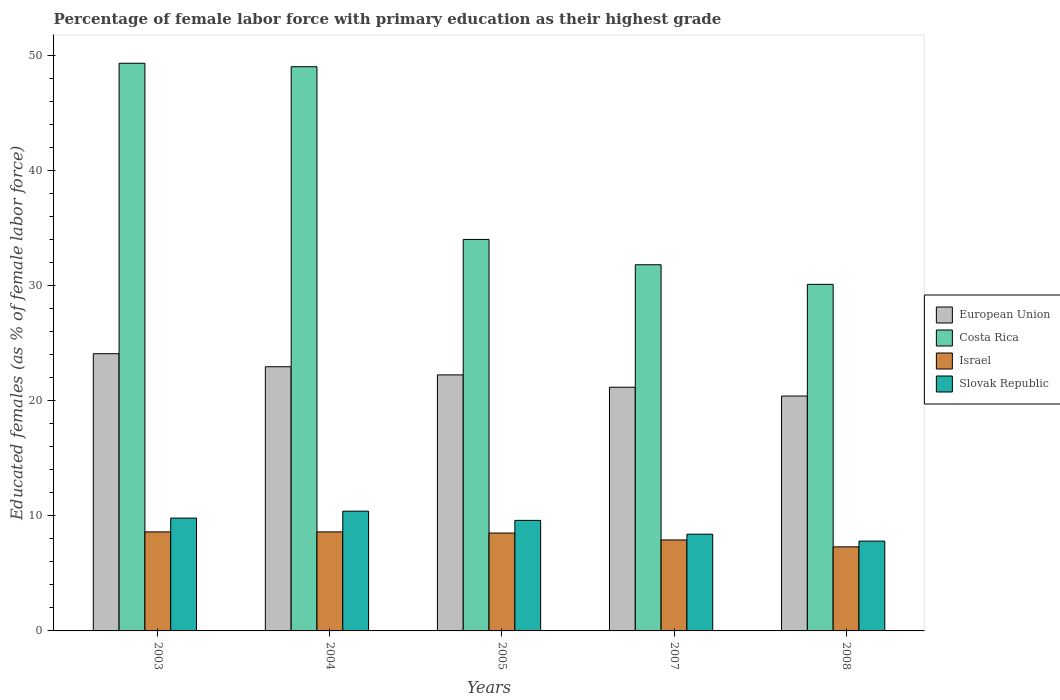How many different coloured bars are there?
Keep it short and to the point. 4. How many bars are there on the 3rd tick from the right?
Provide a short and direct response. 4. What is the label of the 4th group of bars from the left?
Provide a succinct answer. 2007. In how many cases, is the number of bars for a given year not equal to the number of legend labels?
Offer a terse response. 0. What is the percentage of female labor force with primary education in Israel in 2007?
Offer a very short reply. 7.9. Across all years, what is the maximum percentage of female labor force with primary education in Israel?
Give a very brief answer. 8.6. Across all years, what is the minimum percentage of female labor force with primary education in Slovak Republic?
Your response must be concise. 7.8. In which year was the percentage of female labor force with primary education in Israel minimum?
Provide a succinct answer. 2008. What is the total percentage of female labor force with primary education in Slovak Republic in the graph?
Keep it short and to the point. 46. What is the difference between the percentage of female labor force with primary education in Slovak Republic in 2007 and that in 2008?
Keep it short and to the point. 0.6. What is the difference between the percentage of female labor force with primary education in European Union in 2008 and the percentage of female labor force with primary education in Costa Rica in 2007?
Give a very brief answer. -11.4. What is the average percentage of female labor force with primary education in Israel per year?
Keep it short and to the point. 8.18. In the year 2008, what is the difference between the percentage of female labor force with primary education in Slovak Republic and percentage of female labor force with primary education in Israel?
Provide a short and direct response. 0.5. In how many years, is the percentage of female labor force with primary education in Costa Rica greater than 38 %?
Give a very brief answer. 2. What is the ratio of the percentage of female labor force with primary education in Slovak Republic in 2007 to that in 2008?
Ensure brevity in your answer.  1.08. Is the difference between the percentage of female labor force with primary education in Slovak Republic in 2003 and 2008 greater than the difference between the percentage of female labor force with primary education in Israel in 2003 and 2008?
Offer a very short reply. Yes. What is the difference between the highest and the second highest percentage of female labor force with primary education in European Union?
Give a very brief answer. 1.13. What is the difference between the highest and the lowest percentage of female labor force with primary education in Costa Rica?
Make the answer very short. 19.2. In how many years, is the percentage of female labor force with primary education in European Union greater than the average percentage of female labor force with primary education in European Union taken over all years?
Your response must be concise. 3. What does the 4th bar from the left in 2004 represents?
Offer a very short reply. Slovak Republic. What does the 1st bar from the right in 2004 represents?
Offer a very short reply. Slovak Republic. Are all the bars in the graph horizontal?
Your answer should be very brief. No. How many years are there in the graph?
Offer a very short reply. 5. What is the difference between two consecutive major ticks on the Y-axis?
Offer a very short reply. 10. Are the values on the major ticks of Y-axis written in scientific E-notation?
Provide a succinct answer. No. Where does the legend appear in the graph?
Your answer should be compact. Center right. How are the legend labels stacked?
Your answer should be very brief. Vertical. What is the title of the graph?
Offer a terse response. Percentage of female labor force with primary education as their highest grade. Does "St. Martin (French part)" appear as one of the legend labels in the graph?
Provide a short and direct response. No. What is the label or title of the X-axis?
Make the answer very short. Years. What is the label or title of the Y-axis?
Your response must be concise. Educated females (as % of female labor force). What is the Educated females (as % of female labor force) in European Union in 2003?
Ensure brevity in your answer.  24.08. What is the Educated females (as % of female labor force) of Costa Rica in 2003?
Offer a terse response. 49.3. What is the Educated females (as % of female labor force) of Israel in 2003?
Keep it short and to the point. 8.6. What is the Educated females (as % of female labor force) of Slovak Republic in 2003?
Offer a very short reply. 9.8. What is the Educated females (as % of female labor force) of European Union in 2004?
Make the answer very short. 22.94. What is the Educated females (as % of female labor force) of Costa Rica in 2004?
Provide a short and direct response. 49. What is the Educated females (as % of female labor force) of Israel in 2004?
Provide a short and direct response. 8.6. What is the Educated females (as % of female labor force) of Slovak Republic in 2004?
Keep it short and to the point. 10.4. What is the Educated females (as % of female labor force) in European Union in 2005?
Make the answer very short. 22.24. What is the Educated females (as % of female labor force) in Costa Rica in 2005?
Provide a succinct answer. 34. What is the Educated females (as % of female labor force) of Israel in 2005?
Your answer should be very brief. 8.5. What is the Educated females (as % of female labor force) in Slovak Republic in 2005?
Provide a succinct answer. 9.6. What is the Educated females (as % of female labor force) of European Union in 2007?
Make the answer very short. 21.16. What is the Educated females (as % of female labor force) in Costa Rica in 2007?
Your answer should be very brief. 31.8. What is the Educated females (as % of female labor force) of Israel in 2007?
Keep it short and to the point. 7.9. What is the Educated females (as % of female labor force) in Slovak Republic in 2007?
Give a very brief answer. 8.4. What is the Educated females (as % of female labor force) in European Union in 2008?
Offer a terse response. 20.4. What is the Educated females (as % of female labor force) in Costa Rica in 2008?
Provide a short and direct response. 30.1. What is the Educated females (as % of female labor force) of Israel in 2008?
Offer a very short reply. 7.3. What is the Educated females (as % of female labor force) in Slovak Republic in 2008?
Keep it short and to the point. 7.8. Across all years, what is the maximum Educated females (as % of female labor force) in European Union?
Your answer should be compact. 24.08. Across all years, what is the maximum Educated females (as % of female labor force) of Costa Rica?
Your answer should be compact. 49.3. Across all years, what is the maximum Educated females (as % of female labor force) of Israel?
Make the answer very short. 8.6. Across all years, what is the maximum Educated females (as % of female labor force) in Slovak Republic?
Provide a short and direct response. 10.4. Across all years, what is the minimum Educated females (as % of female labor force) of European Union?
Provide a succinct answer. 20.4. Across all years, what is the minimum Educated females (as % of female labor force) in Costa Rica?
Your answer should be very brief. 30.1. Across all years, what is the minimum Educated females (as % of female labor force) of Israel?
Offer a terse response. 7.3. Across all years, what is the minimum Educated females (as % of female labor force) of Slovak Republic?
Your answer should be compact. 7.8. What is the total Educated females (as % of female labor force) in European Union in the graph?
Make the answer very short. 110.82. What is the total Educated females (as % of female labor force) of Costa Rica in the graph?
Your response must be concise. 194.2. What is the total Educated females (as % of female labor force) in Israel in the graph?
Your answer should be compact. 40.9. What is the difference between the Educated females (as % of female labor force) in European Union in 2003 and that in 2004?
Offer a terse response. 1.13. What is the difference between the Educated females (as % of female labor force) of Costa Rica in 2003 and that in 2004?
Your answer should be compact. 0.3. What is the difference between the Educated females (as % of female labor force) of Israel in 2003 and that in 2004?
Keep it short and to the point. 0. What is the difference between the Educated females (as % of female labor force) of Slovak Republic in 2003 and that in 2004?
Offer a terse response. -0.6. What is the difference between the Educated females (as % of female labor force) in European Union in 2003 and that in 2005?
Make the answer very short. 1.84. What is the difference between the Educated females (as % of female labor force) in Slovak Republic in 2003 and that in 2005?
Provide a succinct answer. 0.2. What is the difference between the Educated females (as % of female labor force) in European Union in 2003 and that in 2007?
Offer a terse response. 2.91. What is the difference between the Educated females (as % of female labor force) of Costa Rica in 2003 and that in 2007?
Your answer should be very brief. 17.5. What is the difference between the Educated females (as % of female labor force) in Israel in 2003 and that in 2007?
Offer a very short reply. 0.7. What is the difference between the Educated females (as % of female labor force) of Slovak Republic in 2003 and that in 2007?
Ensure brevity in your answer.  1.4. What is the difference between the Educated females (as % of female labor force) in European Union in 2003 and that in 2008?
Offer a terse response. 3.68. What is the difference between the Educated females (as % of female labor force) in Costa Rica in 2003 and that in 2008?
Your answer should be compact. 19.2. What is the difference between the Educated females (as % of female labor force) of Slovak Republic in 2003 and that in 2008?
Give a very brief answer. 2. What is the difference between the Educated females (as % of female labor force) of European Union in 2004 and that in 2005?
Offer a terse response. 0.71. What is the difference between the Educated females (as % of female labor force) in Costa Rica in 2004 and that in 2005?
Provide a short and direct response. 15. What is the difference between the Educated females (as % of female labor force) of Israel in 2004 and that in 2005?
Your response must be concise. 0.1. What is the difference between the Educated females (as % of female labor force) of European Union in 2004 and that in 2007?
Provide a succinct answer. 1.78. What is the difference between the Educated females (as % of female labor force) of Costa Rica in 2004 and that in 2007?
Provide a succinct answer. 17.2. What is the difference between the Educated females (as % of female labor force) in European Union in 2004 and that in 2008?
Provide a succinct answer. 2.55. What is the difference between the Educated females (as % of female labor force) of Costa Rica in 2004 and that in 2008?
Offer a terse response. 18.9. What is the difference between the Educated females (as % of female labor force) in Slovak Republic in 2004 and that in 2008?
Provide a succinct answer. 2.6. What is the difference between the Educated females (as % of female labor force) in European Union in 2005 and that in 2007?
Your answer should be compact. 1.07. What is the difference between the Educated females (as % of female labor force) of Israel in 2005 and that in 2007?
Ensure brevity in your answer.  0.6. What is the difference between the Educated females (as % of female labor force) in Slovak Republic in 2005 and that in 2007?
Give a very brief answer. 1.2. What is the difference between the Educated females (as % of female labor force) in European Union in 2005 and that in 2008?
Ensure brevity in your answer.  1.84. What is the difference between the Educated females (as % of female labor force) of Costa Rica in 2005 and that in 2008?
Your response must be concise. 3.9. What is the difference between the Educated females (as % of female labor force) of Israel in 2005 and that in 2008?
Make the answer very short. 1.2. What is the difference between the Educated females (as % of female labor force) of European Union in 2007 and that in 2008?
Offer a very short reply. 0.76. What is the difference between the Educated females (as % of female labor force) in Costa Rica in 2007 and that in 2008?
Offer a terse response. 1.7. What is the difference between the Educated females (as % of female labor force) of Israel in 2007 and that in 2008?
Your answer should be compact. 0.6. What is the difference between the Educated females (as % of female labor force) of European Union in 2003 and the Educated females (as % of female labor force) of Costa Rica in 2004?
Your answer should be very brief. -24.92. What is the difference between the Educated females (as % of female labor force) of European Union in 2003 and the Educated females (as % of female labor force) of Israel in 2004?
Keep it short and to the point. 15.48. What is the difference between the Educated females (as % of female labor force) of European Union in 2003 and the Educated females (as % of female labor force) of Slovak Republic in 2004?
Ensure brevity in your answer.  13.68. What is the difference between the Educated females (as % of female labor force) of Costa Rica in 2003 and the Educated females (as % of female labor force) of Israel in 2004?
Offer a terse response. 40.7. What is the difference between the Educated females (as % of female labor force) in Costa Rica in 2003 and the Educated females (as % of female labor force) in Slovak Republic in 2004?
Provide a succinct answer. 38.9. What is the difference between the Educated females (as % of female labor force) of European Union in 2003 and the Educated females (as % of female labor force) of Costa Rica in 2005?
Keep it short and to the point. -9.92. What is the difference between the Educated females (as % of female labor force) in European Union in 2003 and the Educated females (as % of female labor force) in Israel in 2005?
Provide a short and direct response. 15.58. What is the difference between the Educated females (as % of female labor force) in European Union in 2003 and the Educated females (as % of female labor force) in Slovak Republic in 2005?
Offer a very short reply. 14.48. What is the difference between the Educated females (as % of female labor force) in Costa Rica in 2003 and the Educated females (as % of female labor force) in Israel in 2005?
Give a very brief answer. 40.8. What is the difference between the Educated females (as % of female labor force) in Costa Rica in 2003 and the Educated females (as % of female labor force) in Slovak Republic in 2005?
Make the answer very short. 39.7. What is the difference between the Educated females (as % of female labor force) in European Union in 2003 and the Educated females (as % of female labor force) in Costa Rica in 2007?
Keep it short and to the point. -7.72. What is the difference between the Educated females (as % of female labor force) of European Union in 2003 and the Educated females (as % of female labor force) of Israel in 2007?
Keep it short and to the point. 16.18. What is the difference between the Educated females (as % of female labor force) in European Union in 2003 and the Educated females (as % of female labor force) in Slovak Republic in 2007?
Your response must be concise. 15.68. What is the difference between the Educated females (as % of female labor force) in Costa Rica in 2003 and the Educated females (as % of female labor force) in Israel in 2007?
Your answer should be compact. 41.4. What is the difference between the Educated females (as % of female labor force) of Costa Rica in 2003 and the Educated females (as % of female labor force) of Slovak Republic in 2007?
Your answer should be compact. 40.9. What is the difference between the Educated females (as % of female labor force) in European Union in 2003 and the Educated females (as % of female labor force) in Costa Rica in 2008?
Ensure brevity in your answer.  -6.02. What is the difference between the Educated females (as % of female labor force) in European Union in 2003 and the Educated females (as % of female labor force) in Israel in 2008?
Keep it short and to the point. 16.78. What is the difference between the Educated females (as % of female labor force) of European Union in 2003 and the Educated females (as % of female labor force) of Slovak Republic in 2008?
Offer a very short reply. 16.28. What is the difference between the Educated females (as % of female labor force) in Costa Rica in 2003 and the Educated females (as % of female labor force) in Israel in 2008?
Your answer should be compact. 42. What is the difference between the Educated females (as % of female labor force) in Costa Rica in 2003 and the Educated females (as % of female labor force) in Slovak Republic in 2008?
Your answer should be compact. 41.5. What is the difference between the Educated females (as % of female labor force) of Israel in 2003 and the Educated females (as % of female labor force) of Slovak Republic in 2008?
Keep it short and to the point. 0.8. What is the difference between the Educated females (as % of female labor force) of European Union in 2004 and the Educated females (as % of female labor force) of Costa Rica in 2005?
Ensure brevity in your answer.  -11.06. What is the difference between the Educated females (as % of female labor force) of European Union in 2004 and the Educated females (as % of female labor force) of Israel in 2005?
Make the answer very short. 14.44. What is the difference between the Educated females (as % of female labor force) of European Union in 2004 and the Educated females (as % of female labor force) of Slovak Republic in 2005?
Your response must be concise. 13.34. What is the difference between the Educated females (as % of female labor force) of Costa Rica in 2004 and the Educated females (as % of female labor force) of Israel in 2005?
Make the answer very short. 40.5. What is the difference between the Educated females (as % of female labor force) of Costa Rica in 2004 and the Educated females (as % of female labor force) of Slovak Republic in 2005?
Make the answer very short. 39.4. What is the difference between the Educated females (as % of female labor force) of Israel in 2004 and the Educated females (as % of female labor force) of Slovak Republic in 2005?
Offer a terse response. -1. What is the difference between the Educated females (as % of female labor force) of European Union in 2004 and the Educated females (as % of female labor force) of Costa Rica in 2007?
Your response must be concise. -8.86. What is the difference between the Educated females (as % of female labor force) in European Union in 2004 and the Educated females (as % of female labor force) in Israel in 2007?
Offer a terse response. 15.04. What is the difference between the Educated females (as % of female labor force) in European Union in 2004 and the Educated females (as % of female labor force) in Slovak Republic in 2007?
Make the answer very short. 14.54. What is the difference between the Educated females (as % of female labor force) of Costa Rica in 2004 and the Educated females (as % of female labor force) of Israel in 2007?
Provide a succinct answer. 41.1. What is the difference between the Educated females (as % of female labor force) of Costa Rica in 2004 and the Educated females (as % of female labor force) of Slovak Republic in 2007?
Your answer should be compact. 40.6. What is the difference between the Educated females (as % of female labor force) of European Union in 2004 and the Educated females (as % of female labor force) of Costa Rica in 2008?
Your response must be concise. -7.16. What is the difference between the Educated females (as % of female labor force) in European Union in 2004 and the Educated females (as % of female labor force) in Israel in 2008?
Offer a terse response. 15.64. What is the difference between the Educated females (as % of female labor force) of European Union in 2004 and the Educated females (as % of female labor force) of Slovak Republic in 2008?
Give a very brief answer. 15.14. What is the difference between the Educated females (as % of female labor force) of Costa Rica in 2004 and the Educated females (as % of female labor force) of Israel in 2008?
Offer a very short reply. 41.7. What is the difference between the Educated females (as % of female labor force) in Costa Rica in 2004 and the Educated females (as % of female labor force) in Slovak Republic in 2008?
Your response must be concise. 41.2. What is the difference between the Educated females (as % of female labor force) of Israel in 2004 and the Educated females (as % of female labor force) of Slovak Republic in 2008?
Provide a short and direct response. 0.8. What is the difference between the Educated females (as % of female labor force) of European Union in 2005 and the Educated females (as % of female labor force) of Costa Rica in 2007?
Offer a terse response. -9.56. What is the difference between the Educated females (as % of female labor force) of European Union in 2005 and the Educated females (as % of female labor force) of Israel in 2007?
Offer a terse response. 14.34. What is the difference between the Educated females (as % of female labor force) in European Union in 2005 and the Educated females (as % of female labor force) in Slovak Republic in 2007?
Ensure brevity in your answer.  13.84. What is the difference between the Educated females (as % of female labor force) in Costa Rica in 2005 and the Educated females (as % of female labor force) in Israel in 2007?
Offer a very short reply. 26.1. What is the difference between the Educated females (as % of female labor force) in Costa Rica in 2005 and the Educated females (as % of female labor force) in Slovak Republic in 2007?
Provide a short and direct response. 25.6. What is the difference between the Educated females (as % of female labor force) of European Union in 2005 and the Educated females (as % of female labor force) of Costa Rica in 2008?
Provide a succinct answer. -7.86. What is the difference between the Educated females (as % of female labor force) of European Union in 2005 and the Educated females (as % of female labor force) of Israel in 2008?
Keep it short and to the point. 14.94. What is the difference between the Educated females (as % of female labor force) of European Union in 2005 and the Educated females (as % of female labor force) of Slovak Republic in 2008?
Offer a terse response. 14.44. What is the difference between the Educated females (as % of female labor force) of Costa Rica in 2005 and the Educated females (as % of female labor force) of Israel in 2008?
Keep it short and to the point. 26.7. What is the difference between the Educated females (as % of female labor force) in Costa Rica in 2005 and the Educated females (as % of female labor force) in Slovak Republic in 2008?
Keep it short and to the point. 26.2. What is the difference between the Educated females (as % of female labor force) in European Union in 2007 and the Educated females (as % of female labor force) in Costa Rica in 2008?
Your response must be concise. -8.94. What is the difference between the Educated females (as % of female labor force) in European Union in 2007 and the Educated females (as % of female labor force) in Israel in 2008?
Your response must be concise. 13.86. What is the difference between the Educated females (as % of female labor force) in European Union in 2007 and the Educated females (as % of female labor force) in Slovak Republic in 2008?
Give a very brief answer. 13.36. What is the difference between the Educated females (as % of female labor force) of Costa Rica in 2007 and the Educated females (as % of female labor force) of Israel in 2008?
Provide a succinct answer. 24.5. What is the difference between the Educated females (as % of female labor force) in Costa Rica in 2007 and the Educated females (as % of female labor force) in Slovak Republic in 2008?
Your response must be concise. 24. What is the average Educated females (as % of female labor force) of European Union per year?
Ensure brevity in your answer.  22.16. What is the average Educated females (as % of female labor force) in Costa Rica per year?
Offer a very short reply. 38.84. What is the average Educated females (as % of female labor force) in Israel per year?
Give a very brief answer. 8.18. What is the average Educated females (as % of female labor force) in Slovak Republic per year?
Provide a short and direct response. 9.2. In the year 2003, what is the difference between the Educated females (as % of female labor force) of European Union and Educated females (as % of female labor force) of Costa Rica?
Your answer should be compact. -25.22. In the year 2003, what is the difference between the Educated females (as % of female labor force) of European Union and Educated females (as % of female labor force) of Israel?
Provide a succinct answer. 15.48. In the year 2003, what is the difference between the Educated females (as % of female labor force) of European Union and Educated females (as % of female labor force) of Slovak Republic?
Keep it short and to the point. 14.28. In the year 2003, what is the difference between the Educated females (as % of female labor force) of Costa Rica and Educated females (as % of female labor force) of Israel?
Your answer should be compact. 40.7. In the year 2003, what is the difference between the Educated females (as % of female labor force) of Costa Rica and Educated females (as % of female labor force) of Slovak Republic?
Offer a very short reply. 39.5. In the year 2004, what is the difference between the Educated females (as % of female labor force) in European Union and Educated females (as % of female labor force) in Costa Rica?
Keep it short and to the point. -26.06. In the year 2004, what is the difference between the Educated females (as % of female labor force) of European Union and Educated females (as % of female labor force) of Israel?
Your response must be concise. 14.34. In the year 2004, what is the difference between the Educated females (as % of female labor force) in European Union and Educated females (as % of female labor force) in Slovak Republic?
Provide a succinct answer. 12.54. In the year 2004, what is the difference between the Educated females (as % of female labor force) in Costa Rica and Educated females (as % of female labor force) in Israel?
Offer a very short reply. 40.4. In the year 2004, what is the difference between the Educated females (as % of female labor force) in Costa Rica and Educated females (as % of female labor force) in Slovak Republic?
Your answer should be compact. 38.6. In the year 2005, what is the difference between the Educated females (as % of female labor force) in European Union and Educated females (as % of female labor force) in Costa Rica?
Give a very brief answer. -11.76. In the year 2005, what is the difference between the Educated females (as % of female labor force) in European Union and Educated females (as % of female labor force) in Israel?
Ensure brevity in your answer.  13.74. In the year 2005, what is the difference between the Educated females (as % of female labor force) in European Union and Educated females (as % of female labor force) in Slovak Republic?
Offer a terse response. 12.64. In the year 2005, what is the difference between the Educated females (as % of female labor force) of Costa Rica and Educated females (as % of female labor force) of Slovak Republic?
Give a very brief answer. 24.4. In the year 2005, what is the difference between the Educated females (as % of female labor force) in Israel and Educated females (as % of female labor force) in Slovak Republic?
Provide a succinct answer. -1.1. In the year 2007, what is the difference between the Educated females (as % of female labor force) in European Union and Educated females (as % of female labor force) in Costa Rica?
Offer a terse response. -10.64. In the year 2007, what is the difference between the Educated females (as % of female labor force) of European Union and Educated females (as % of female labor force) of Israel?
Your answer should be compact. 13.26. In the year 2007, what is the difference between the Educated females (as % of female labor force) of European Union and Educated females (as % of female labor force) of Slovak Republic?
Your answer should be very brief. 12.76. In the year 2007, what is the difference between the Educated females (as % of female labor force) in Costa Rica and Educated females (as % of female labor force) in Israel?
Offer a very short reply. 23.9. In the year 2007, what is the difference between the Educated females (as % of female labor force) of Costa Rica and Educated females (as % of female labor force) of Slovak Republic?
Ensure brevity in your answer.  23.4. In the year 2008, what is the difference between the Educated females (as % of female labor force) of European Union and Educated females (as % of female labor force) of Costa Rica?
Provide a succinct answer. -9.7. In the year 2008, what is the difference between the Educated females (as % of female labor force) in European Union and Educated females (as % of female labor force) in Israel?
Ensure brevity in your answer.  13.1. In the year 2008, what is the difference between the Educated females (as % of female labor force) of European Union and Educated females (as % of female labor force) of Slovak Republic?
Your response must be concise. 12.6. In the year 2008, what is the difference between the Educated females (as % of female labor force) of Costa Rica and Educated females (as % of female labor force) of Israel?
Ensure brevity in your answer.  22.8. In the year 2008, what is the difference between the Educated females (as % of female labor force) in Costa Rica and Educated females (as % of female labor force) in Slovak Republic?
Keep it short and to the point. 22.3. In the year 2008, what is the difference between the Educated females (as % of female labor force) in Israel and Educated females (as % of female labor force) in Slovak Republic?
Offer a terse response. -0.5. What is the ratio of the Educated females (as % of female labor force) in European Union in 2003 to that in 2004?
Your response must be concise. 1.05. What is the ratio of the Educated females (as % of female labor force) in Costa Rica in 2003 to that in 2004?
Give a very brief answer. 1.01. What is the ratio of the Educated females (as % of female labor force) of Israel in 2003 to that in 2004?
Your answer should be very brief. 1. What is the ratio of the Educated females (as % of female labor force) in Slovak Republic in 2003 to that in 2004?
Your answer should be compact. 0.94. What is the ratio of the Educated females (as % of female labor force) in European Union in 2003 to that in 2005?
Provide a short and direct response. 1.08. What is the ratio of the Educated females (as % of female labor force) of Costa Rica in 2003 to that in 2005?
Make the answer very short. 1.45. What is the ratio of the Educated females (as % of female labor force) in Israel in 2003 to that in 2005?
Your response must be concise. 1.01. What is the ratio of the Educated females (as % of female labor force) of Slovak Republic in 2003 to that in 2005?
Keep it short and to the point. 1.02. What is the ratio of the Educated females (as % of female labor force) in European Union in 2003 to that in 2007?
Your response must be concise. 1.14. What is the ratio of the Educated females (as % of female labor force) in Costa Rica in 2003 to that in 2007?
Provide a short and direct response. 1.55. What is the ratio of the Educated females (as % of female labor force) in Israel in 2003 to that in 2007?
Keep it short and to the point. 1.09. What is the ratio of the Educated females (as % of female labor force) of Slovak Republic in 2003 to that in 2007?
Make the answer very short. 1.17. What is the ratio of the Educated females (as % of female labor force) of European Union in 2003 to that in 2008?
Provide a succinct answer. 1.18. What is the ratio of the Educated females (as % of female labor force) of Costa Rica in 2003 to that in 2008?
Your answer should be very brief. 1.64. What is the ratio of the Educated females (as % of female labor force) of Israel in 2003 to that in 2008?
Keep it short and to the point. 1.18. What is the ratio of the Educated females (as % of female labor force) of Slovak Republic in 2003 to that in 2008?
Offer a terse response. 1.26. What is the ratio of the Educated females (as % of female labor force) in European Union in 2004 to that in 2005?
Your response must be concise. 1.03. What is the ratio of the Educated females (as % of female labor force) in Costa Rica in 2004 to that in 2005?
Offer a very short reply. 1.44. What is the ratio of the Educated females (as % of female labor force) of Israel in 2004 to that in 2005?
Make the answer very short. 1.01. What is the ratio of the Educated females (as % of female labor force) in Slovak Republic in 2004 to that in 2005?
Keep it short and to the point. 1.08. What is the ratio of the Educated females (as % of female labor force) of European Union in 2004 to that in 2007?
Ensure brevity in your answer.  1.08. What is the ratio of the Educated females (as % of female labor force) of Costa Rica in 2004 to that in 2007?
Provide a short and direct response. 1.54. What is the ratio of the Educated females (as % of female labor force) in Israel in 2004 to that in 2007?
Ensure brevity in your answer.  1.09. What is the ratio of the Educated females (as % of female labor force) in Slovak Republic in 2004 to that in 2007?
Provide a short and direct response. 1.24. What is the ratio of the Educated females (as % of female labor force) in European Union in 2004 to that in 2008?
Your answer should be very brief. 1.12. What is the ratio of the Educated females (as % of female labor force) in Costa Rica in 2004 to that in 2008?
Your answer should be very brief. 1.63. What is the ratio of the Educated females (as % of female labor force) in Israel in 2004 to that in 2008?
Your answer should be very brief. 1.18. What is the ratio of the Educated females (as % of female labor force) in European Union in 2005 to that in 2007?
Keep it short and to the point. 1.05. What is the ratio of the Educated females (as % of female labor force) in Costa Rica in 2005 to that in 2007?
Keep it short and to the point. 1.07. What is the ratio of the Educated females (as % of female labor force) of Israel in 2005 to that in 2007?
Provide a short and direct response. 1.08. What is the ratio of the Educated females (as % of female labor force) in European Union in 2005 to that in 2008?
Provide a succinct answer. 1.09. What is the ratio of the Educated females (as % of female labor force) in Costa Rica in 2005 to that in 2008?
Ensure brevity in your answer.  1.13. What is the ratio of the Educated females (as % of female labor force) of Israel in 2005 to that in 2008?
Your answer should be very brief. 1.16. What is the ratio of the Educated females (as % of female labor force) of Slovak Republic in 2005 to that in 2008?
Provide a short and direct response. 1.23. What is the ratio of the Educated females (as % of female labor force) of European Union in 2007 to that in 2008?
Provide a short and direct response. 1.04. What is the ratio of the Educated females (as % of female labor force) in Costa Rica in 2007 to that in 2008?
Make the answer very short. 1.06. What is the ratio of the Educated females (as % of female labor force) in Israel in 2007 to that in 2008?
Your answer should be very brief. 1.08. What is the difference between the highest and the second highest Educated females (as % of female labor force) of European Union?
Keep it short and to the point. 1.13. What is the difference between the highest and the second highest Educated females (as % of female labor force) of Costa Rica?
Keep it short and to the point. 0.3. What is the difference between the highest and the lowest Educated females (as % of female labor force) of European Union?
Your response must be concise. 3.68. What is the difference between the highest and the lowest Educated females (as % of female labor force) in Slovak Republic?
Offer a very short reply. 2.6. 